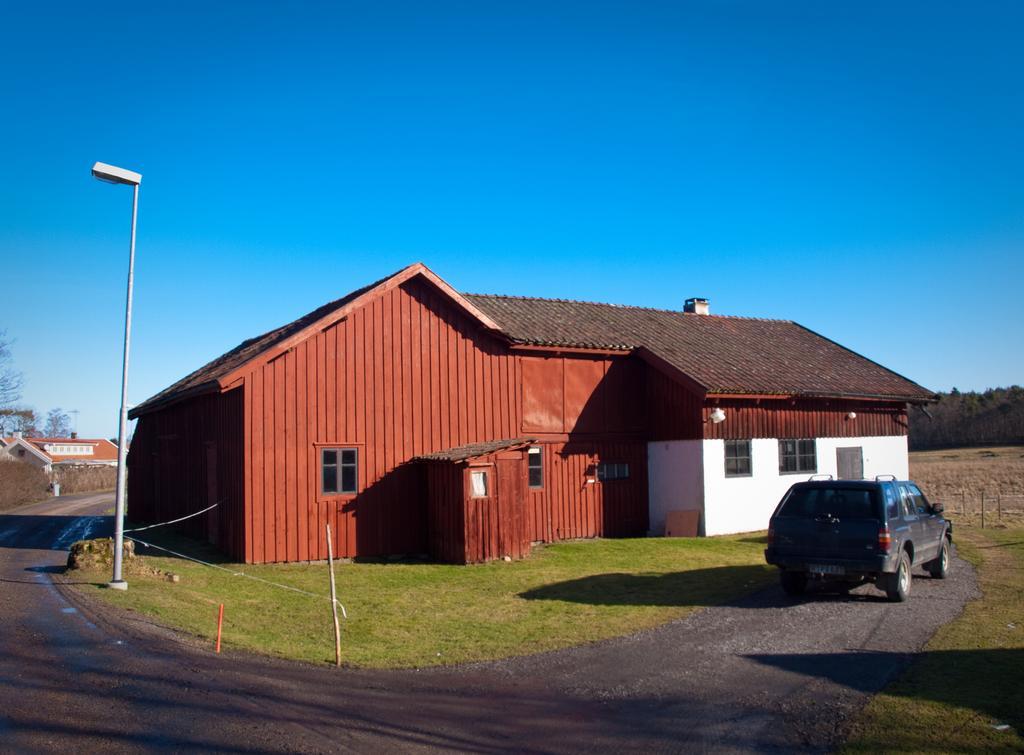In one or two sentences, can you explain what this image depicts? in this picture I see couple of houses and trees and a pole light and I see a car parked, it is black in color and grass on the ground and a blue sky. 